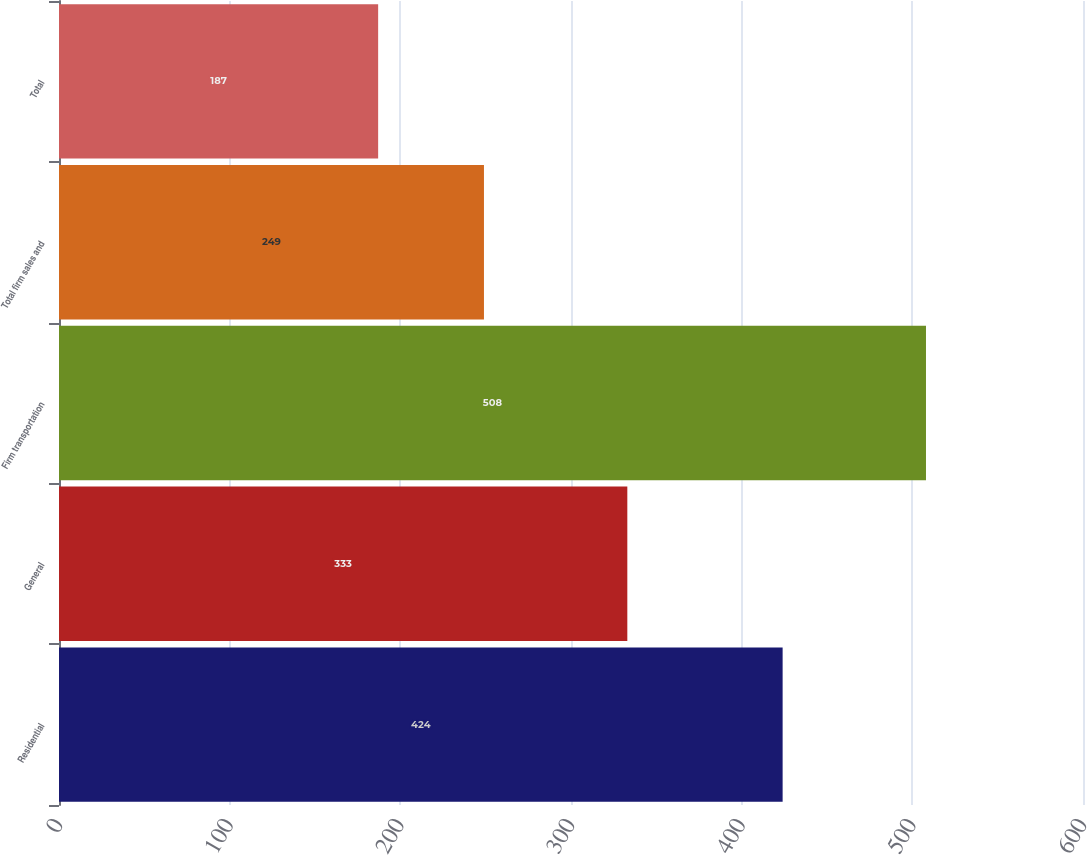<chart> <loc_0><loc_0><loc_500><loc_500><bar_chart><fcel>Residential<fcel>General<fcel>Firm transportation<fcel>Total firm sales and<fcel>Total<nl><fcel>424<fcel>333<fcel>508<fcel>249<fcel>187<nl></chart> 